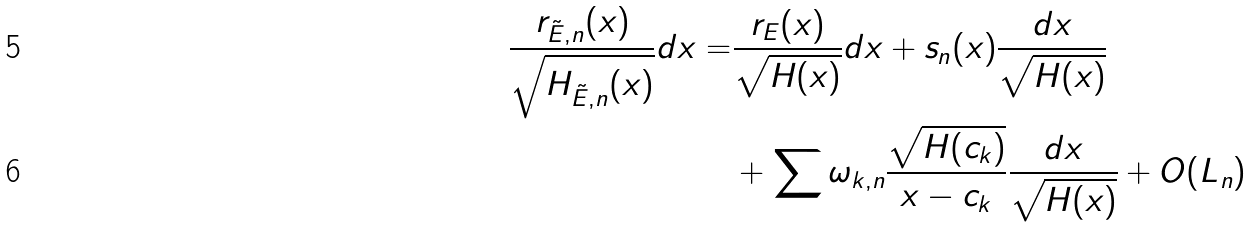<formula> <loc_0><loc_0><loc_500><loc_500>\frac { r _ { \tilde { E } , n } ( x ) } { \sqrt { H _ { \tilde { E } , n } ( x ) } } d x = & \frac { r _ { E } ( x ) } { \sqrt { H ( x ) } } d x + s _ { n } ( x ) \frac { d x } { \sqrt { H ( x ) } } \\ & + \sum \omega _ { k , n } \frac { \sqrt { H ( c _ { k } ) } } { x - c _ { k } } \frac { d x } { \sqrt { H ( x ) } } + O ( L _ { n } )</formula> 